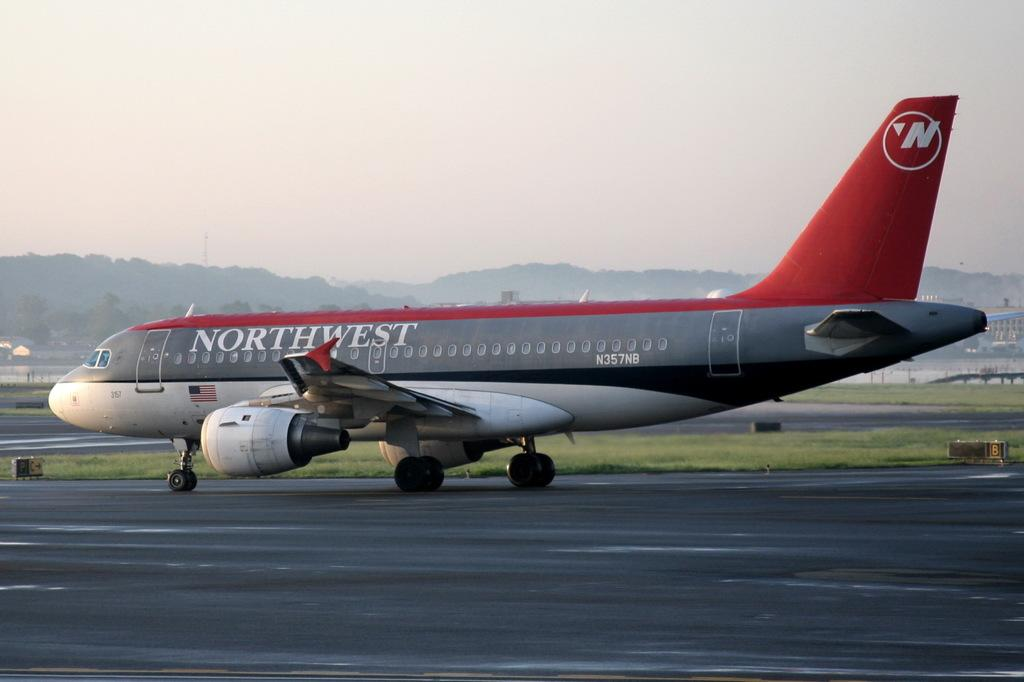<image>
Describe the image concisely. A gray and red Northwest airplane is parked on the runway. 